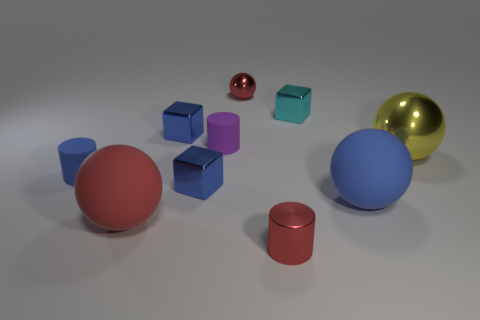There is a metal object that is the same color as the metal cylinder; what is its size?
Your answer should be compact. Small. The red object that is the same shape as the small blue matte object is what size?
Keep it short and to the point. Small. Do the metal cylinder and the big rubber thing to the left of the small shiny ball have the same color?
Offer a terse response. Yes. Does the small ball have the same color as the small metallic cylinder?
Offer a terse response. Yes. Do the blue thing on the right side of the metal cylinder and the tiny purple object have the same material?
Your response must be concise. Yes. There is a large thing that is left of the shiny cube in front of the large sphere to the right of the blue matte sphere; what shape is it?
Give a very brief answer. Sphere. Is the number of tiny red cylinders to the left of the tiny red metallic cylinder less than the number of small red metal things that are left of the tiny purple thing?
Give a very brief answer. No. There is a red rubber sphere that is to the left of the metallic cube on the right side of the metal ball behind the yellow shiny object; what is its size?
Provide a succinct answer. Large. What size is the ball that is on the left side of the cyan cube and in front of the big yellow metal ball?
Your answer should be compact. Large. The tiny matte object to the right of the small rubber object to the left of the large red matte object is what shape?
Provide a short and direct response. Cylinder. 